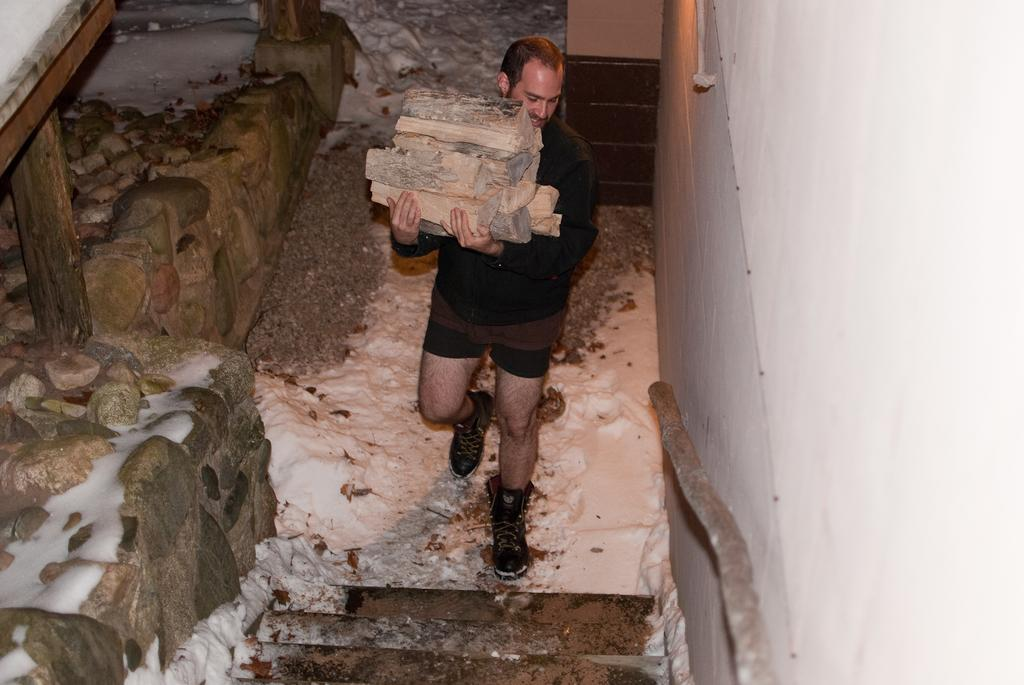Who or what is present in the image? There is a person in the image. What is the person holding in the image? The person is holding wooden blocks. What other objects can be seen near the person? There are rocks beside the person. What is the condition of the rocks in the image? There is snow on top of the rocks. What type of meat is being cooked on the skate in the image? There is no meat or skate present in the image; it features a person holding wooden blocks and rocks with snow on top. 